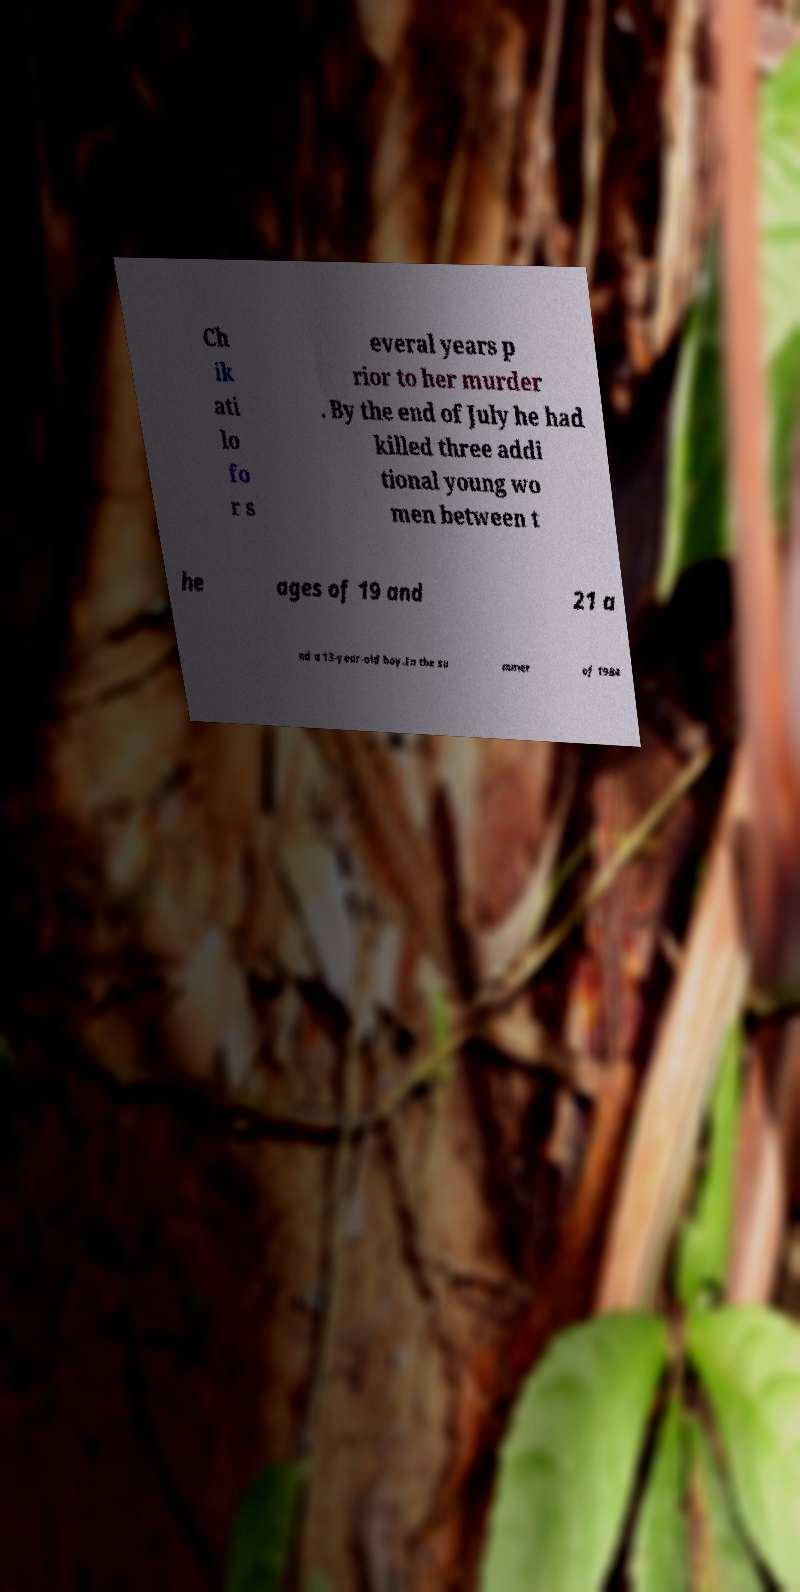Can you read and provide the text displayed in the image?This photo seems to have some interesting text. Can you extract and type it out for me? Ch ik ati lo fo r s everal years p rior to her murder . By the end of July he had killed three addi tional young wo men between t he ages of 19 and 21 a nd a 13-year-old boy.In the su mmer of 1984 